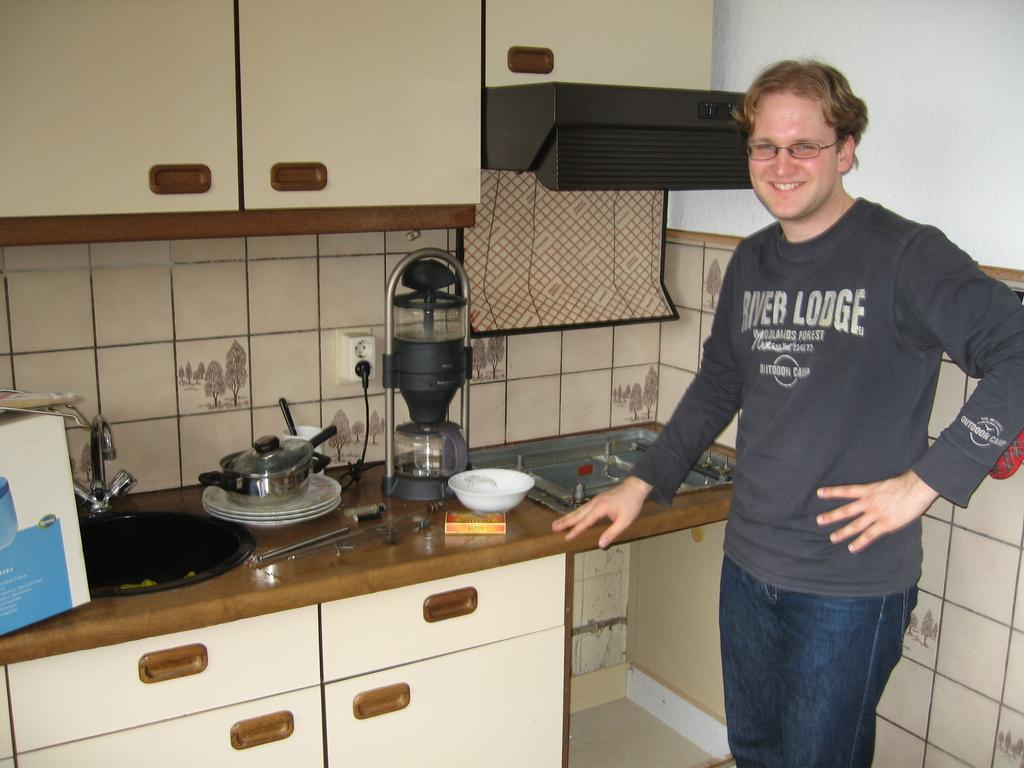<image>
Write a terse but informative summary of the picture. A man in a River Lodge shirt stands in a kitchen. 